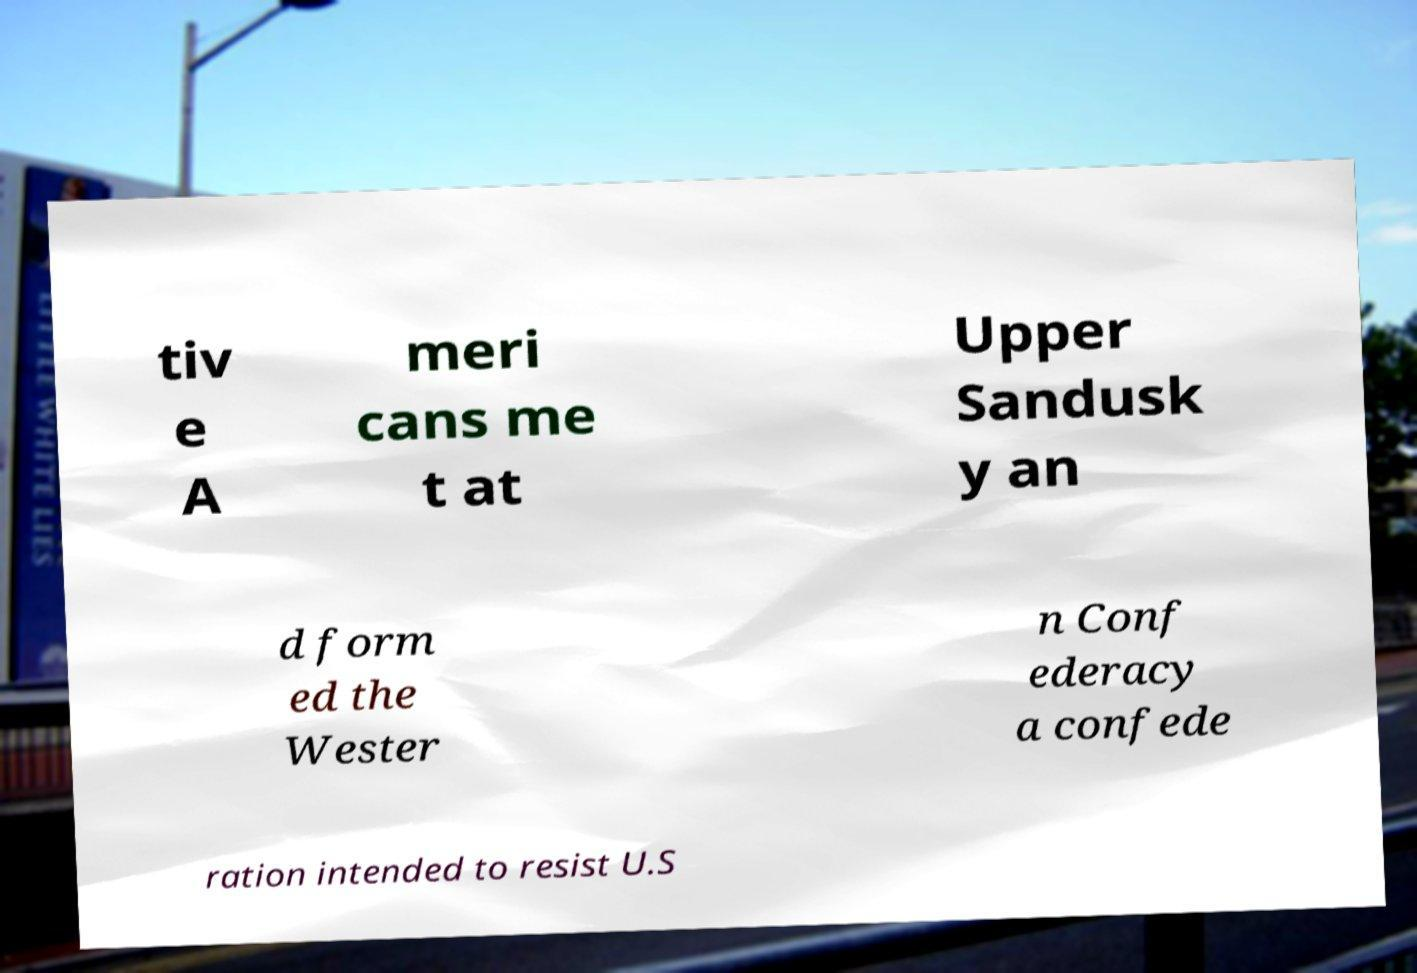Could you assist in decoding the text presented in this image and type it out clearly? tiv e A meri cans me t at Upper Sandusk y an d form ed the Wester n Conf ederacy a confede ration intended to resist U.S 